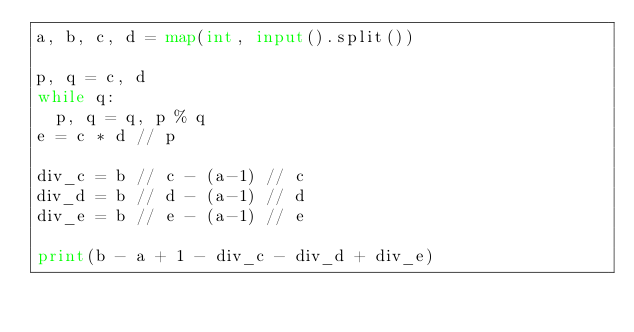Convert code to text. <code><loc_0><loc_0><loc_500><loc_500><_Python_>a, b, c, d = map(int, input().split())

p, q = c, d
while q:
  p, q = q, p % q
e = c * d // p

div_c = b // c - (a-1) // c
div_d = b // d - (a-1) // d
div_e = b // e - (a-1) // e

print(b - a + 1 - div_c - div_d + div_e)</code> 